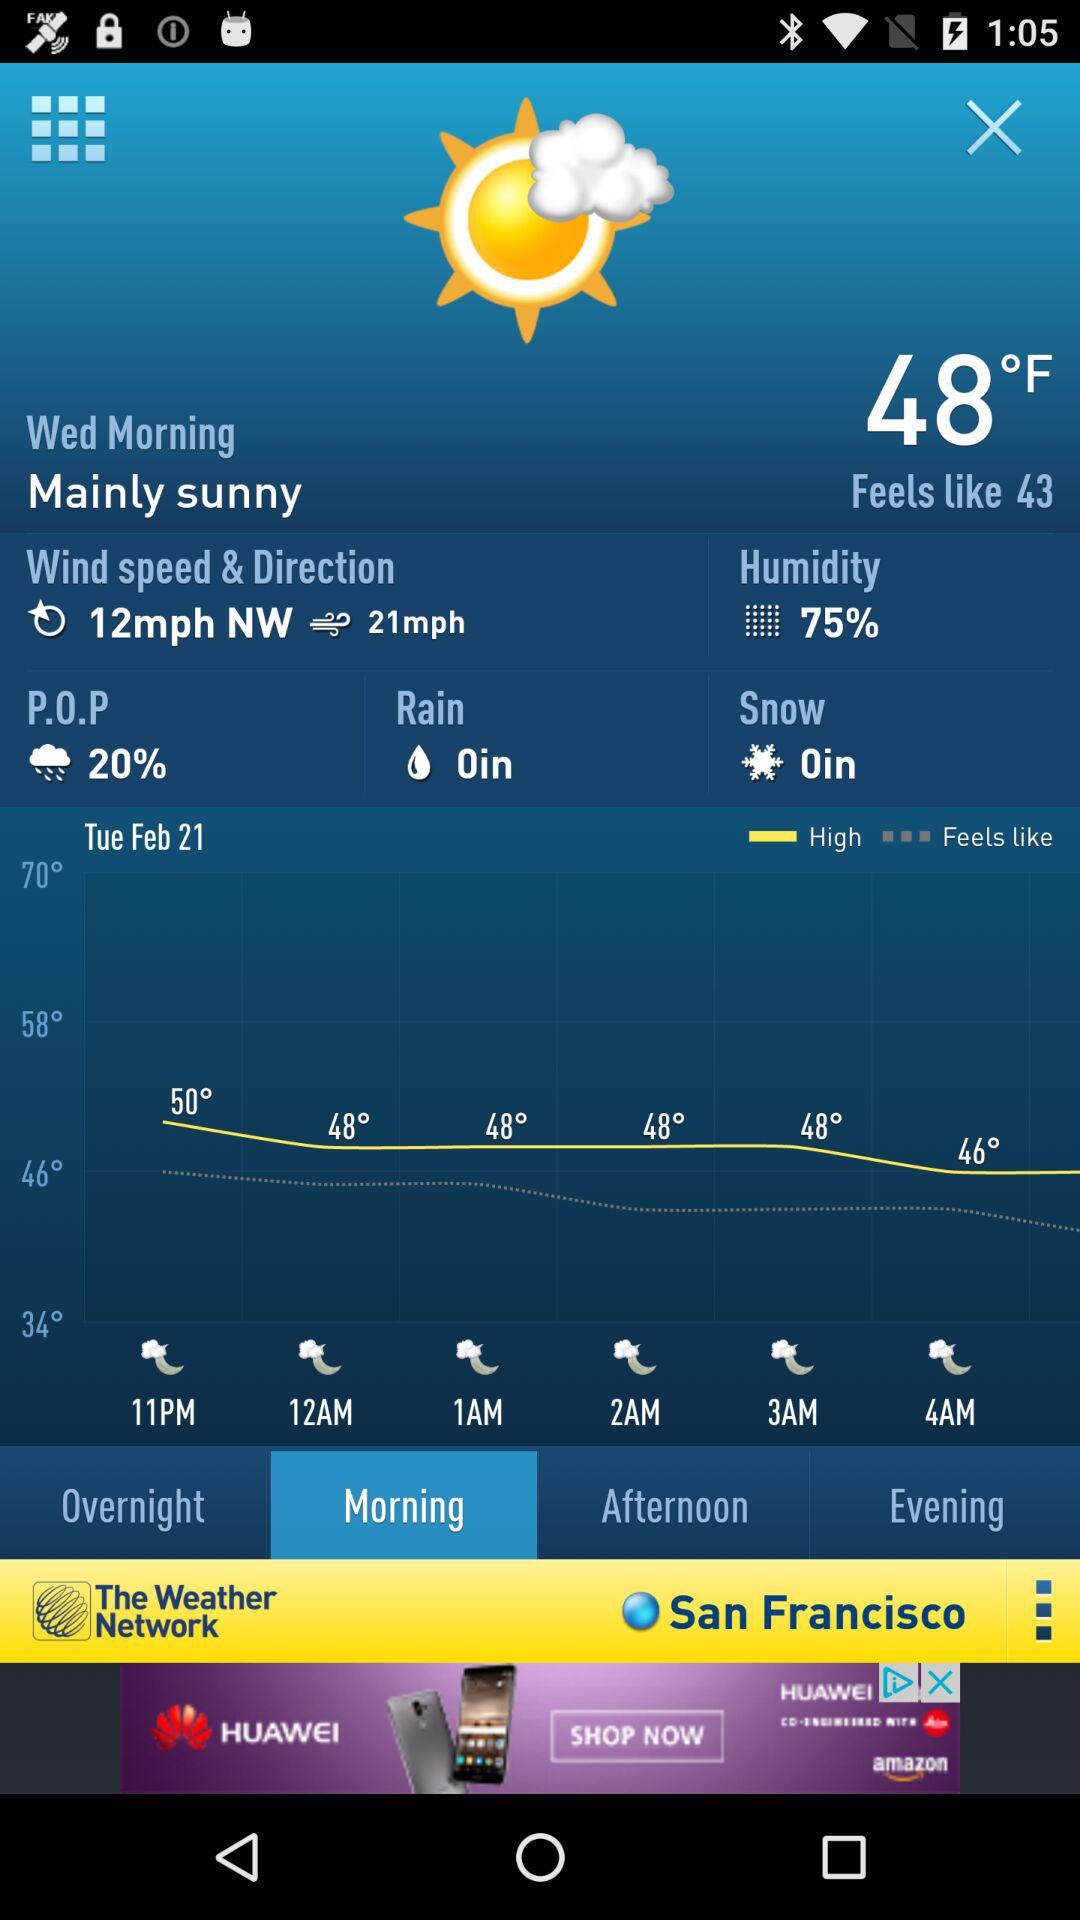What is the percentage of humidity? The percentage of humidity is 75. 